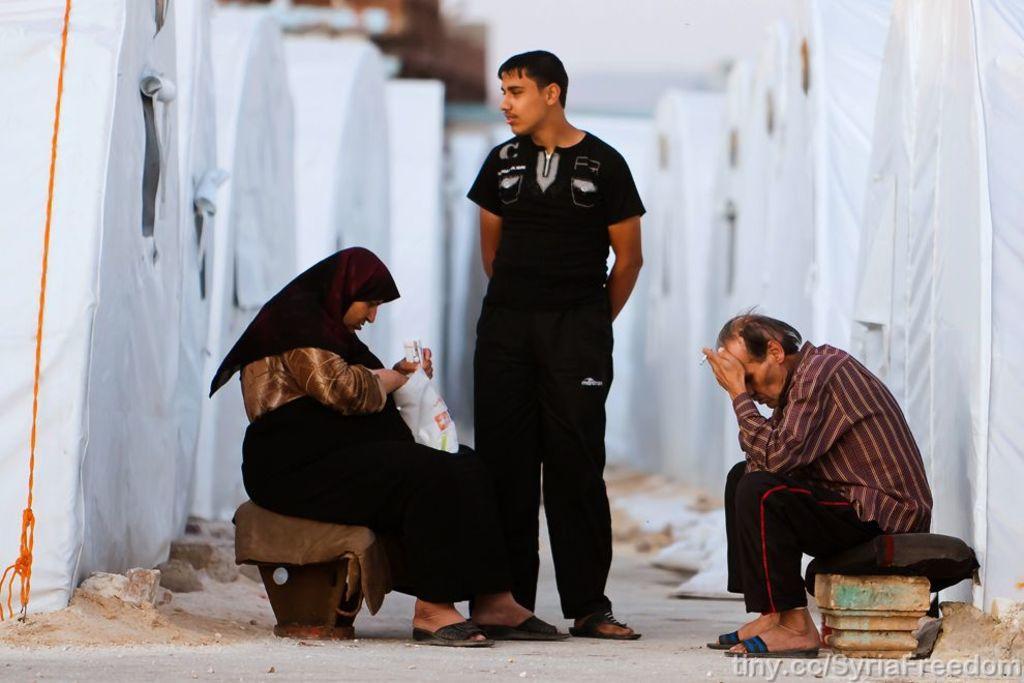How would you summarize this image in a sentence or two? In this image there is a man and a woman sitting, in between them there is a person standing, around them there are some objects covered in white cloth and there is a rope, at the bottom of the image there is some text and there are some rocks on the surface. 